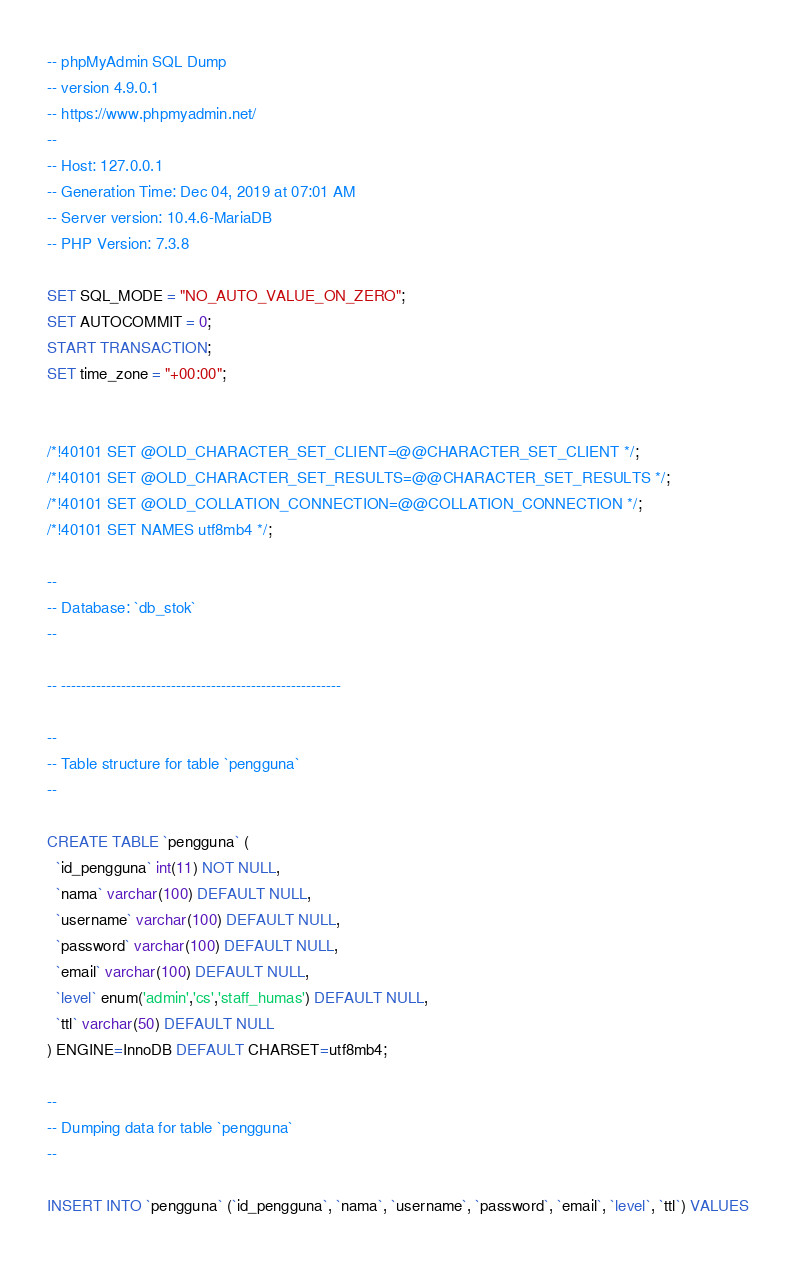Convert code to text. <code><loc_0><loc_0><loc_500><loc_500><_SQL_>-- phpMyAdmin SQL Dump
-- version 4.9.0.1
-- https://www.phpmyadmin.net/
--
-- Host: 127.0.0.1
-- Generation Time: Dec 04, 2019 at 07:01 AM
-- Server version: 10.4.6-MariaDB
-- PHP Version: 7.3.8

SET SQL_MODE = "NO_AUTO_VALUE_ON_ZERO";
SET AUTOCOMMIT = 0;
START TRANSACTION;
SET time_zone = "+00:00";


/*!40101 SET @OLD_CHARACTER_SET_CLIENT=@@CHARACTER_SET_CLIENT */;
/*!40101 SET @OLD_CHARACTER_SET_RESULTS=@@CHARACTER_SET_RESULTS */;
/*!40101 SET @OLD_COLLATION_CONNECTION=@@COLLATION_CONNECTION */;
/*!40101 SET NAMES utf8mb4 */;

--
-- Database: `db_stok`
--

-- --------------------------------------------------------

--
-- Table structure for table `pengguna`
--

CREATE TABLE `pengguna` (
  `id_pengguna` int(11) NOT NULL,
  `nama` varchar(100) DEFAULT NULL,
  `username` varchar(100) DEFAULT NULL,
  `password` varchar(100) DEFAULT NULL,
  `email` varchar(100) DEFAULT NULL,
  `level` enum('admin','cs','staff_humas') DEFAULT NULL,
  `ttl` varchar(50) DEFAULT NULL
) ENGINE=InnoDB DEFAULT CHARSET=utf8mb4;

--
-- Dumping data for table `pengguna`
--

INSERT INTO `pengguna` (`id_pengguna`, `nama`, `username`, `password`, `email`, `level`, `ttl`) VALUES</code> 